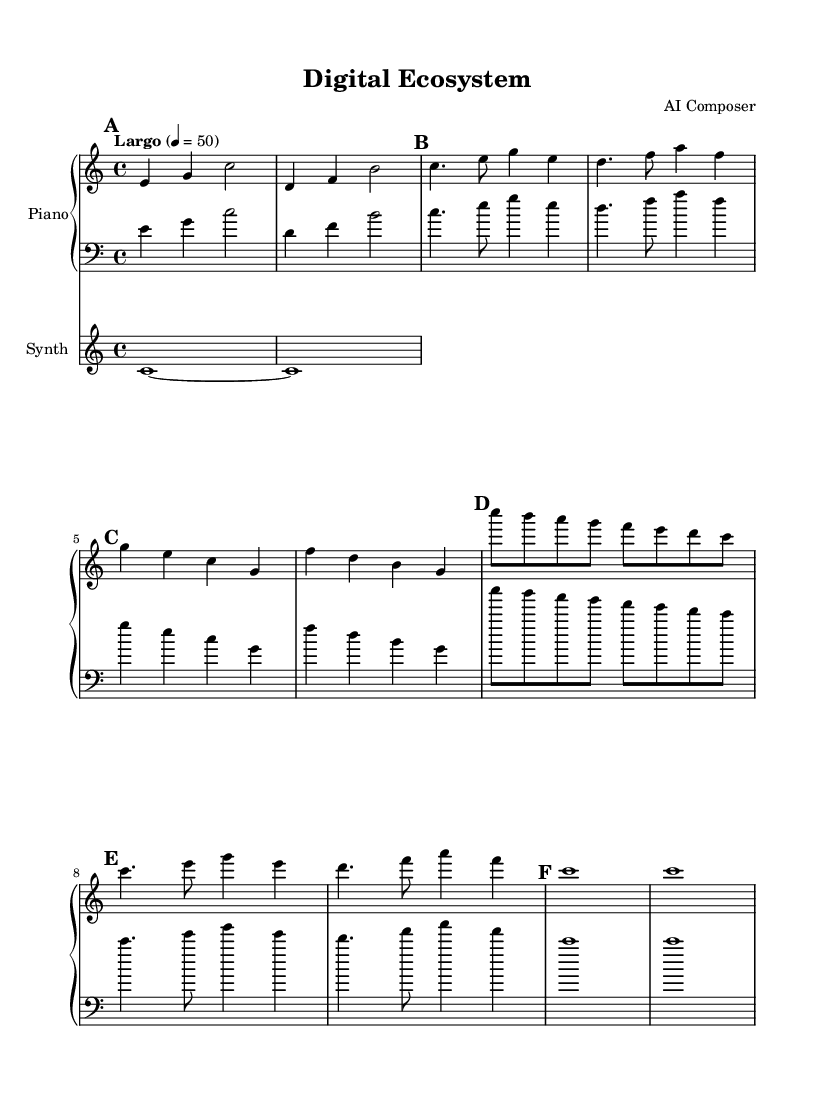What is the key signature of this music? The key signature is C major, which has no sharps or flats.
Answer: C major What is the time signature of this piece? The time signature is indicated at the beginning of the sheet music as 4/4, which means four beats per measure.
Answer: 4/4 What is the tempo of the piece? The tempo is marked as "Largo" with a metronome marking of 50 beats per minute, indicating a slow pace.
Answer: Largo, 50 How many distinct themes are present in the music? Upon examining the score, we can identify three distinct themes: Theme A, Theme B, and a variation of Theme A. Counting these gives us the total.
Answer: 3 What instrument is used for the synthesizer part? The instrument is specified as "pad 2 (warm)" in the synthesizer section of the sheet music, indicating the sound character used.
Answer: pad 2 (warm) What is the duration of the outro section? The outro section consists of two measures, each having a whole note (c1) that lasts for four beats. Summing these gives us the total duration.
Answer: 8 beats What musical technique is primarily used in the interlude? The interlude section features a descending scale pattern from c'' to c, which produces a calm and flowing texture characteristic of ambient music.
Answer: Descending scale 